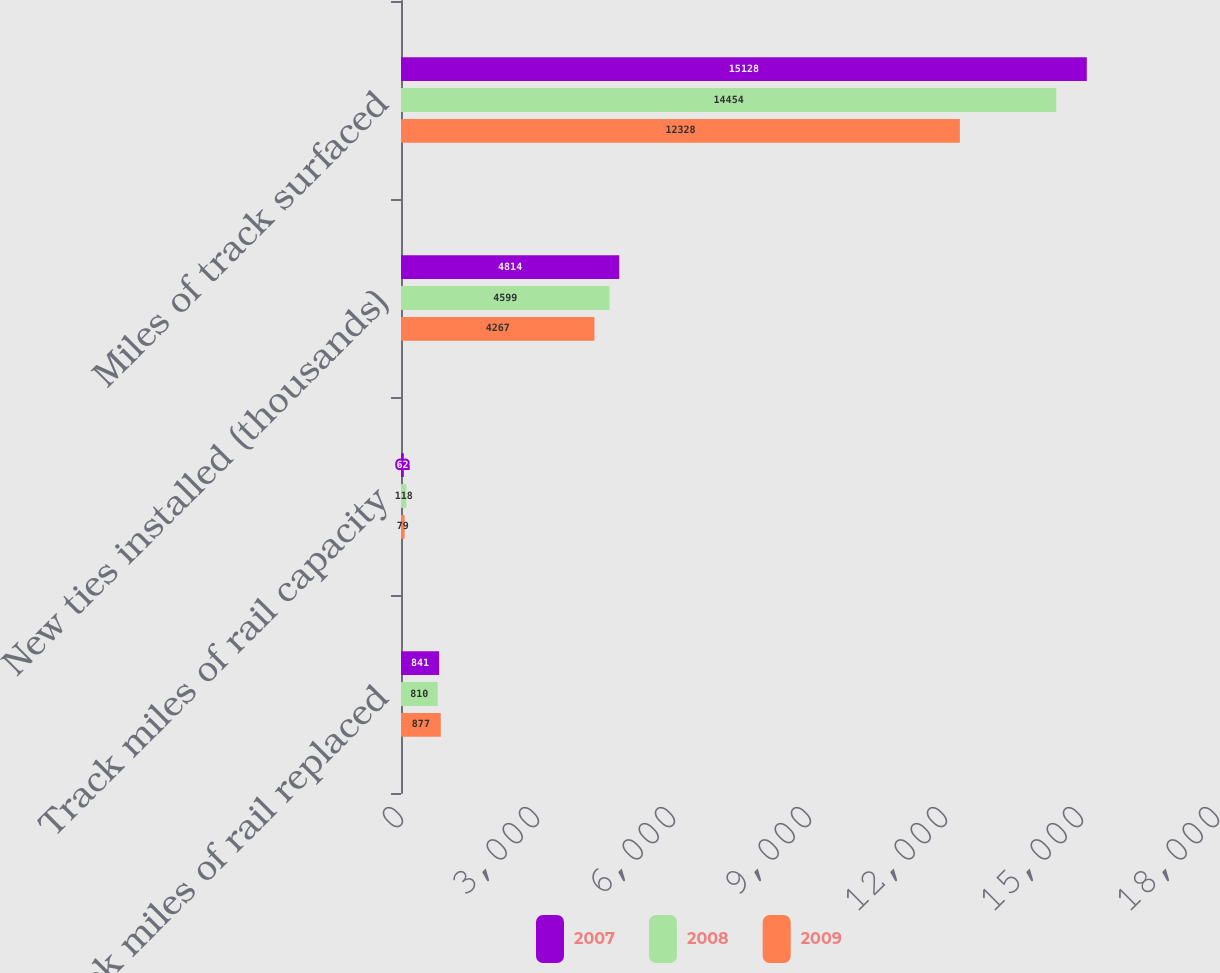<chart> <loc_0><loc_0><loc_500><loc_500><stacked_bar_chart><ecel><fcel>Track miles of rail replaced<fcel>Track miles of rail capacity<fcel>New ties installed (thousands)<fcel>Miles of track surfaced<nl><fcel>2007<fcel>841<fcel>62<fcel>4814<fcel>15128<nl><fcel>2008<fcel>810<fcel>118<fcel>4599<fcel>14454<nl><fcel>2009<fcel>877<fcel>79<fcel>4267<fcel>12328<nl></chart> 